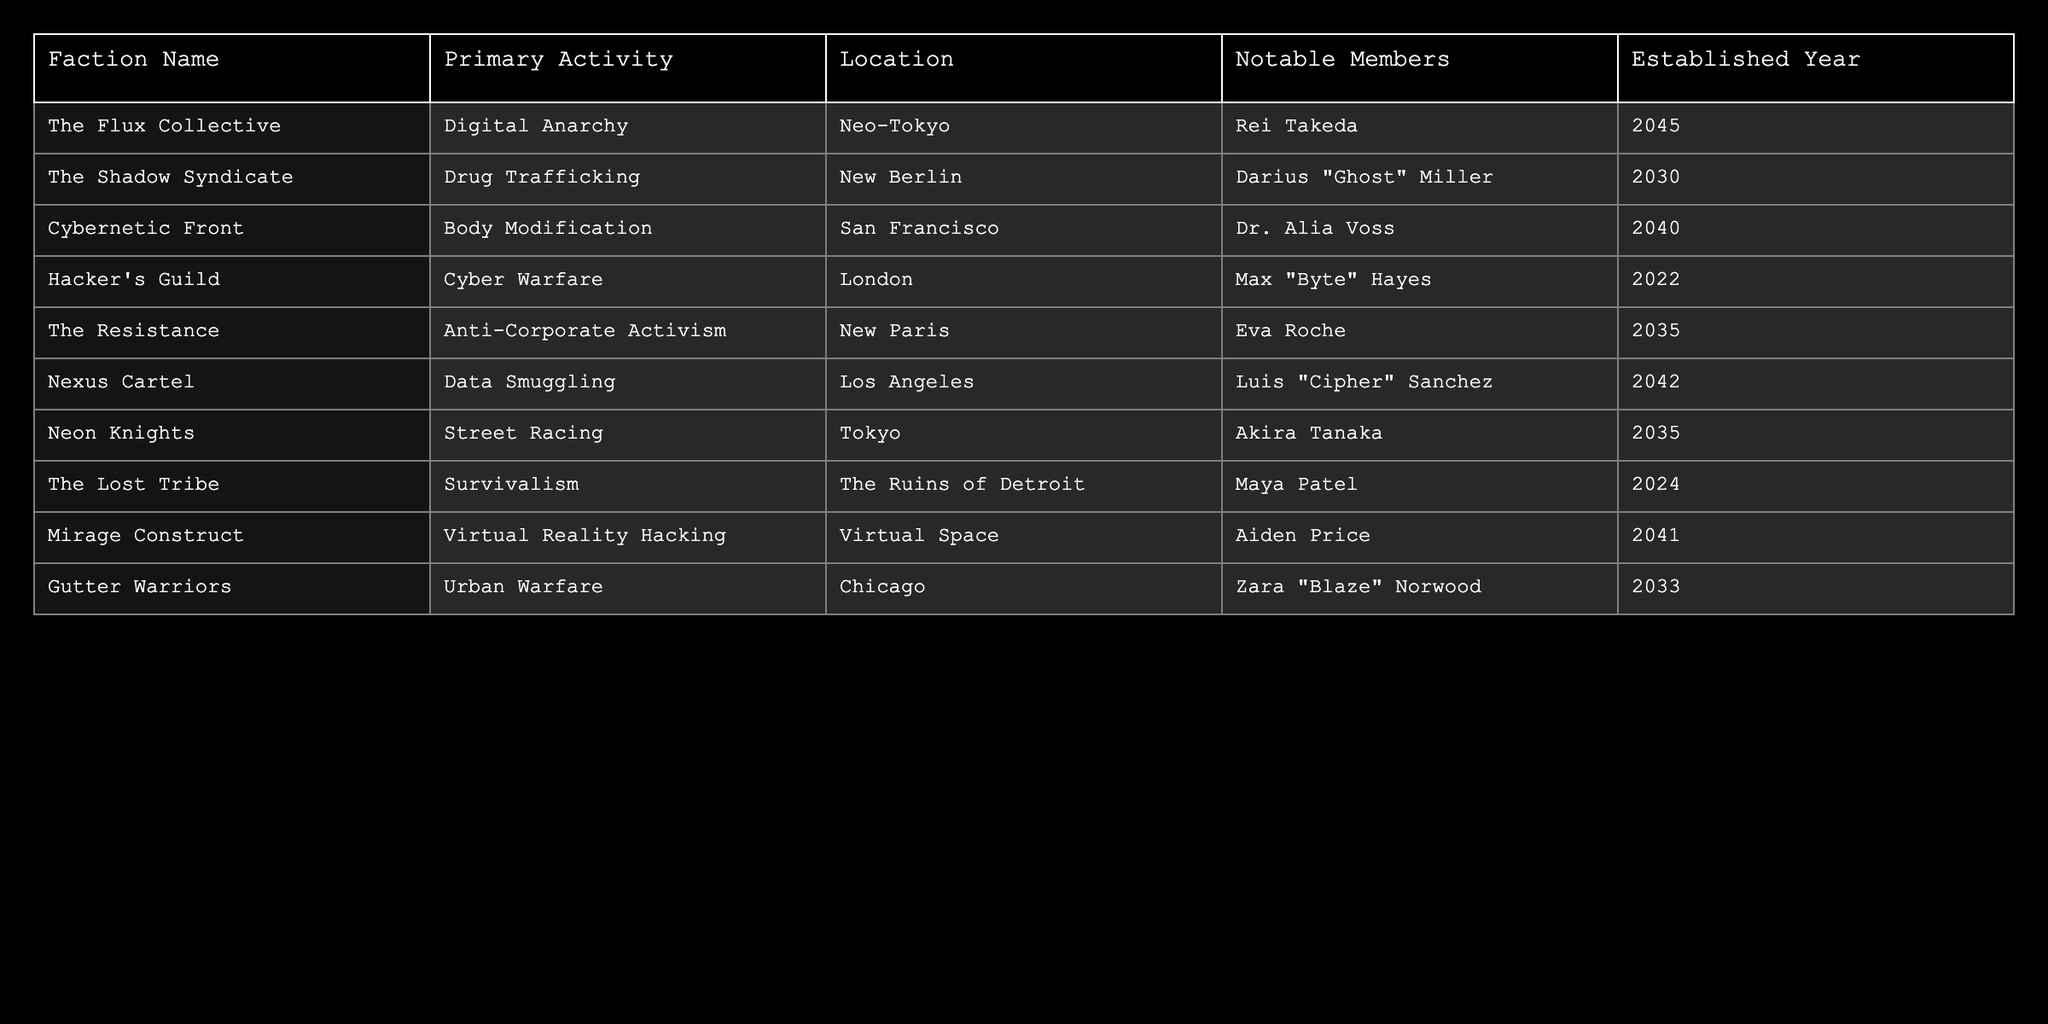What is the primary activity of The Flux Collective? The table indicates that The Flux Collective's primary activity is Digital Anarchy.
Answer: Digital Anarchy Which location is associated with the Hacker's Guild? According to the table, the Hacker's Guild is located in London.
Answer: London How many factions were established in the 2040s? The table lists three factions established in the 2040s: The Flux Collective (2045), Cybernetic Front (2040), and Nexus Cartel (2042).
Answer: 3 Does the table list any faction established before 2020? Reviewing the table, there are no factions established before the year 2020.
Answer: No Which faction has the notable member named Maya Patel? The Lost Tribe has Maya Patel listed as a notable member, according to the table.
Answer: The Lost Tribe What is the difference in establishment years between The Resistance and Cybernetic Front? The Resistance was established in 2035, and Cybernetic Front in 2040. The difference is 2040 - 2035 = 5 years.
Answer: 5 years Is there any faction whose primary activity involves street racing? Yes, the table notes that the Neon Knights are associated with street racing.
Answer: Yes Identify the faction with the longest name and state its activity. The faction with the longest name is The Shadow Syndicate, which is involved in Drug Trafficking.
Answer: The Shadow Syndicate, Drug Trafficking In which city is the Nexus Cartel located, and what is its primary activity? The Nexus Cartel is located in Los Angeles and is involved in Data Smuggling.
Answer: Los Angeles, Data Smuggling Which faction has the highest established year and what is its activity? The faction with the highest established year is The Flux Collective, established in 2045, and its activity is Digital Anarchy.
Answer: The Flux Collective, Digital Anarchy 